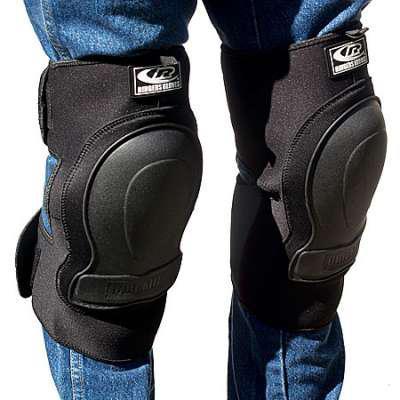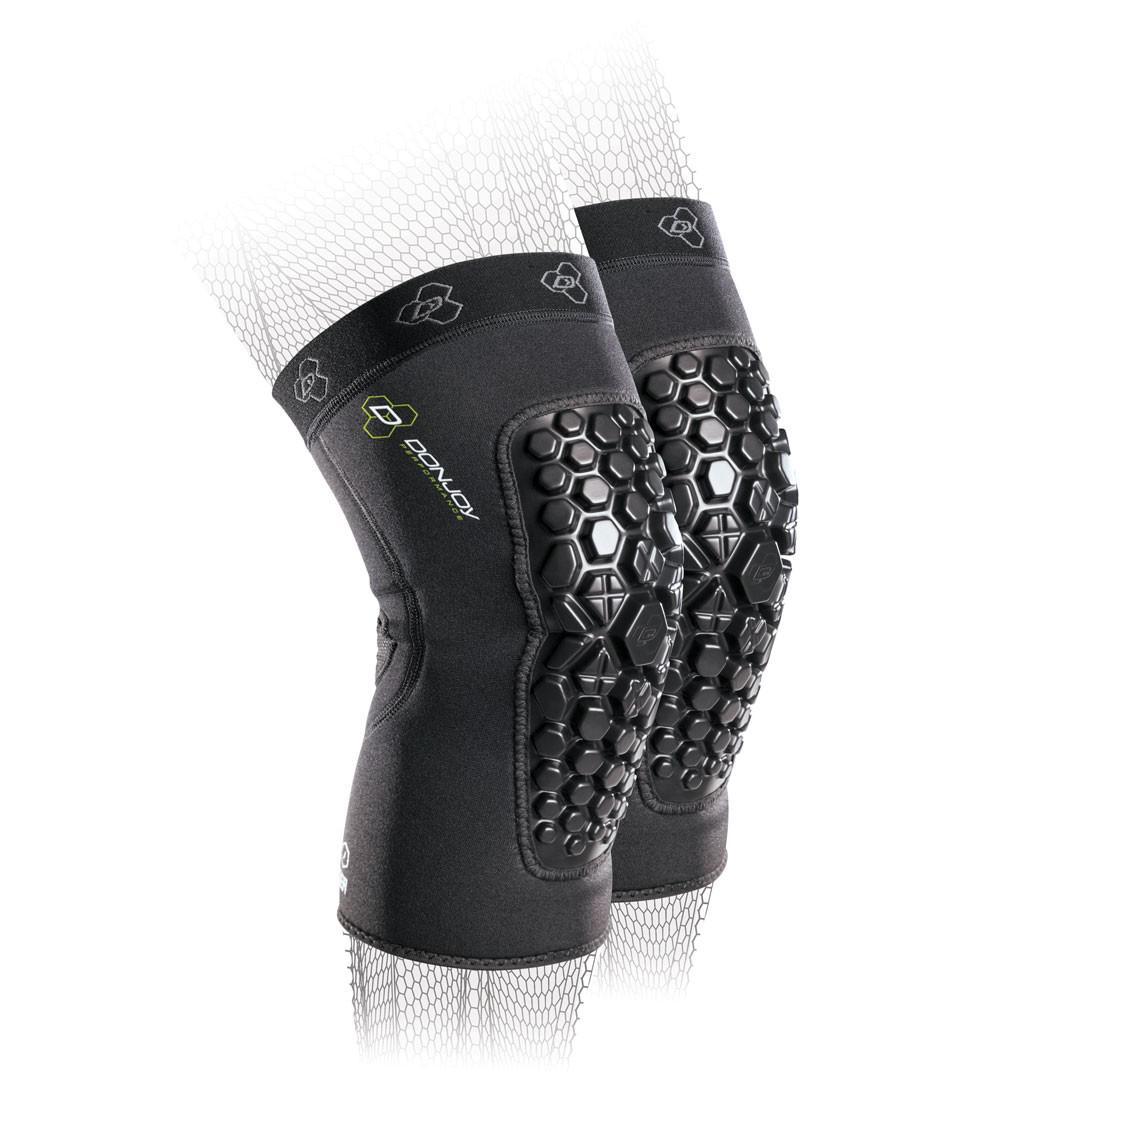The first image is the image on the left, the second image is the image on the right. For the images displayed, is the sentence "At least one kneepad appears to be worn on a leg, and all kneepads are facing rightwards." factually correct? Answer yes or no. Yes. The first image is the image on the left, the second image is the image on the right. Assess this claim about the two images: "Exactly two pairs of knee pads are shown, each solid black with logos, one pair viewed from the front and one at an angle to give a side view.". Correct or not? Answer yes or no. No. 